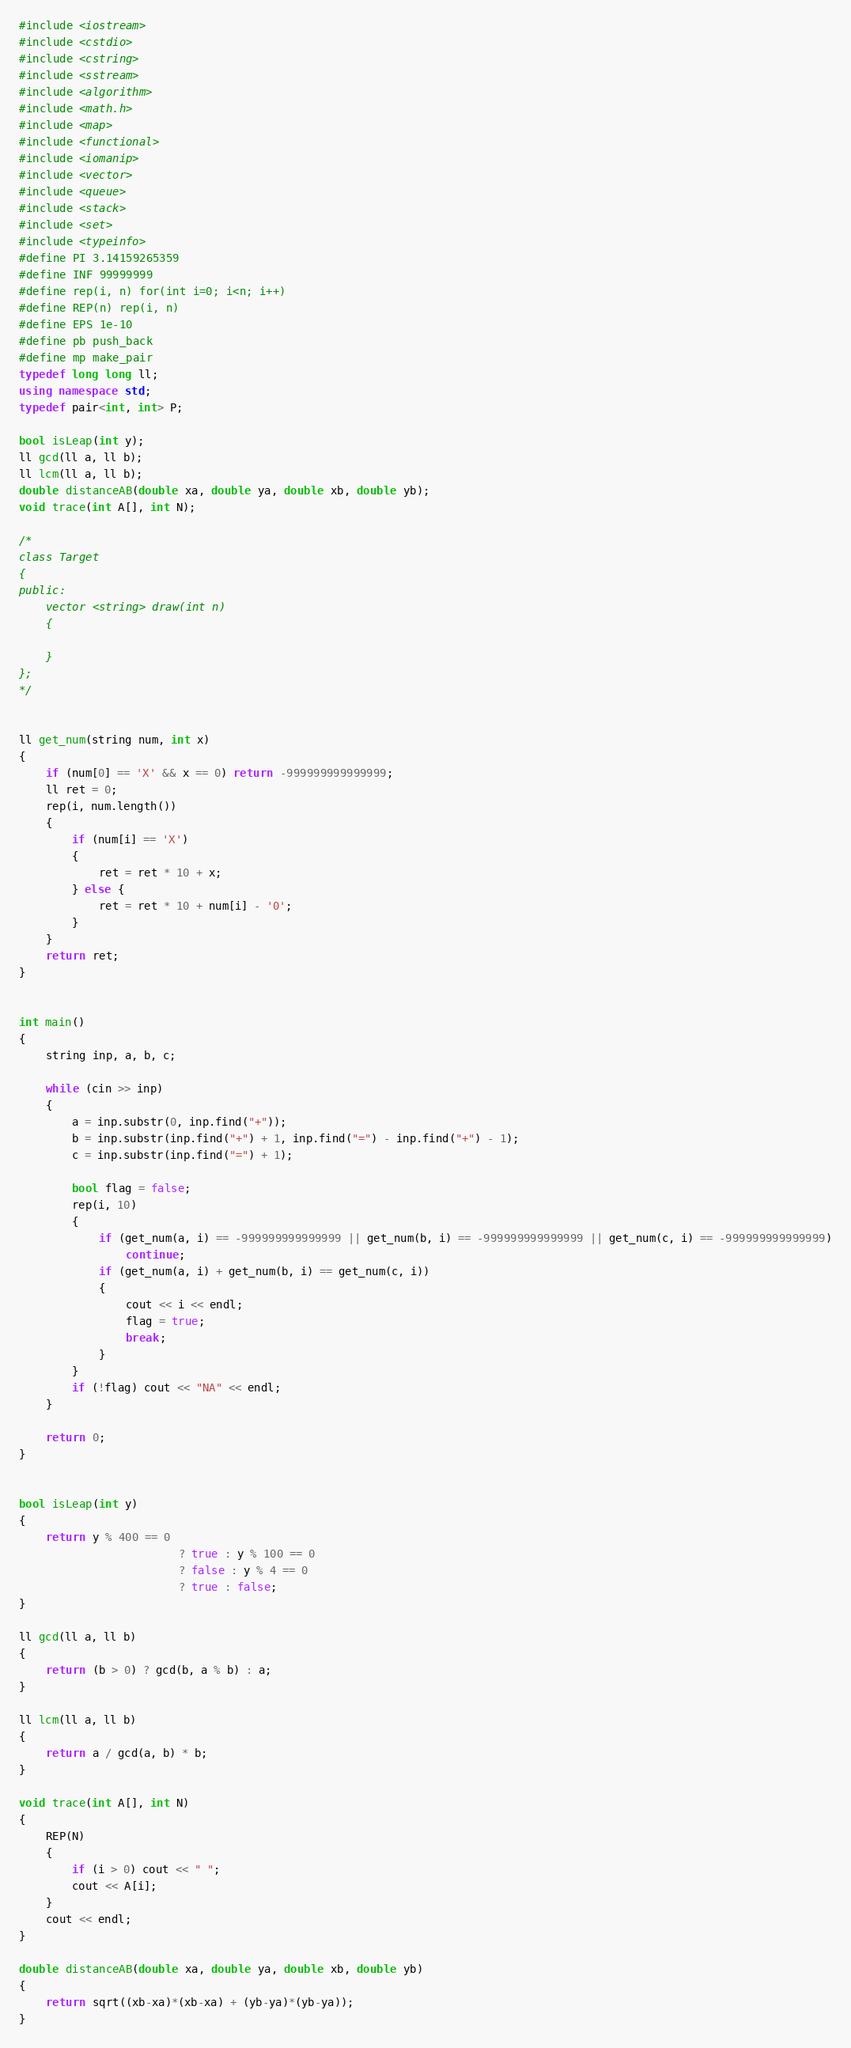Convert code to text. <code><loc_0><loc_0><loc_500><loc_500><_C++_>#include <iostream>
#include <cstdio>
#include <cstring>
#include <sstream>
#include <algorithm>
#include <math.h>
#include <map>
#include <functional>
#include <iomanip>
#include <vector>
#include <queue>
#include <stack>
#include <set>
#include <typeinfo>
#define PI 3.14159265359
#define INF 99999999
#define rep(i, n) for(int i=0; i<n; i++)
#define REP(n) rep(i, n)
#define EPS 1e-10
#define pb push_back
#define mp make_pair
typedef long long ll;
using namespace std;
typedef pair<int, int> P;

bool isLeap(int y);
ll gcd(ll a, ll b);
ll lcm(ll a, ll b);
double distanceAB(double xa, double ya, double xb, double yb);
void trace(int A[], int N);

/*
class Target
{
public:
	vector <string> draw(int n)
	{

	}
};
*/


ll get_num(string num, int x)
{
	if (num[0] == 'X' && x == 0) return -999999999999999;
	ll ret = 0;
	rep(i, num.length())
	{
		if (num[i] == 'X')
		{
			ret = ret * 10 + x;
		} else {
			ret = ret * 10 + num[i] - '0';
		}
	}
	return ret;
}


int main()
{
	string inp, a, b, c;
	
	while (cin >> inp)
	{
		a = inp.substr(0, inp.find("+"));
		b = inp.substr(inp.find("+") + 1, inp.find("=") - inp.find("+") - 1);
		c = inp.substr(inp.find("=") + 1);
		
		bool flag = false;
		rep(i, 10)
		{
			if (get_num(a, i) == -999999999999999 || get_num(b, i) == -999999999999999 || get_num(c, i) == -999999999999999)
				continue;
			if (get_num(a, i) + get_num(b, i) == get_num(c, i))
			{
				cout << i << endl;
				flag = true;
				break;
			}
		}
		if (!flag) cout << "NA" << endl;
	}
	
	return 0;
}


bool isLeap(int y)
{
	return y % 400 == 0
						? true : y % 100 == 0
						? false : y % 4 == 0
						? true : false;
}

ll gcd(ll a, ll b)
{
	return (b > 0) ? gcd(b, a % b) : a;
}

ll lcm(ll a, ll b)
{
	return a / gcd(a, b) * b;
}

void trace(int A[], int N)
{
	REP(N)
	{
		if (i > 0) cout << " ";
		cout << A[i];
	}
	cout << endl;
}

double distanceAB(double xa, double ya, double xb, double yb)
{
	return sqrt((xb-xa)*(xb-xa) + (yb-ya)*(yb-ya));
}</code> 